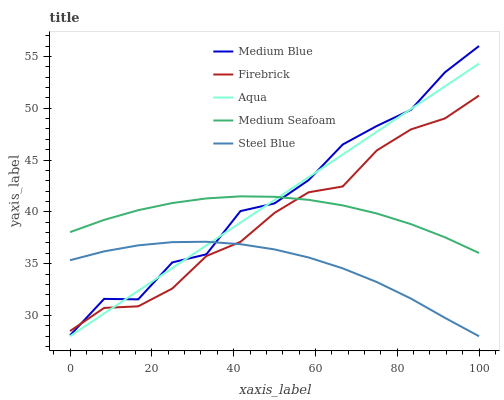Does Steel Blue have the minimum area under the curve?
Answer yes or no. Yes. Does Medium Blue have the maximum area under the curve?
Answer yes or no. Yes. Does Firebrick have the minimum area under the curve?
Answer yes or no. No. Does Firebrick have the maximum area under the curve?
Answer yes or no. No. Is Aqua the smoothest?
Answer yes or no. Yes. Is Medium Blue the roughest?
Answer yes or no. Yes. Is Firebrick the smoothest?
Answer yes or no. No. Is Firebrick the roughest?
Answer yes or no. No. Does Firebrick have the lowest value?
Answer yes or no. No. Does Firebrick have the highest value?
Answer yes or no. No. Is Steel Blue less than Medium Seafoam?
Answer yes or no. Yes. Is Medium Seafoam greater than Steel Blue?
Answer yes or no. Yes. Does Steel Blue intersect Medium Seafoam?
Answer yes or no. No. 